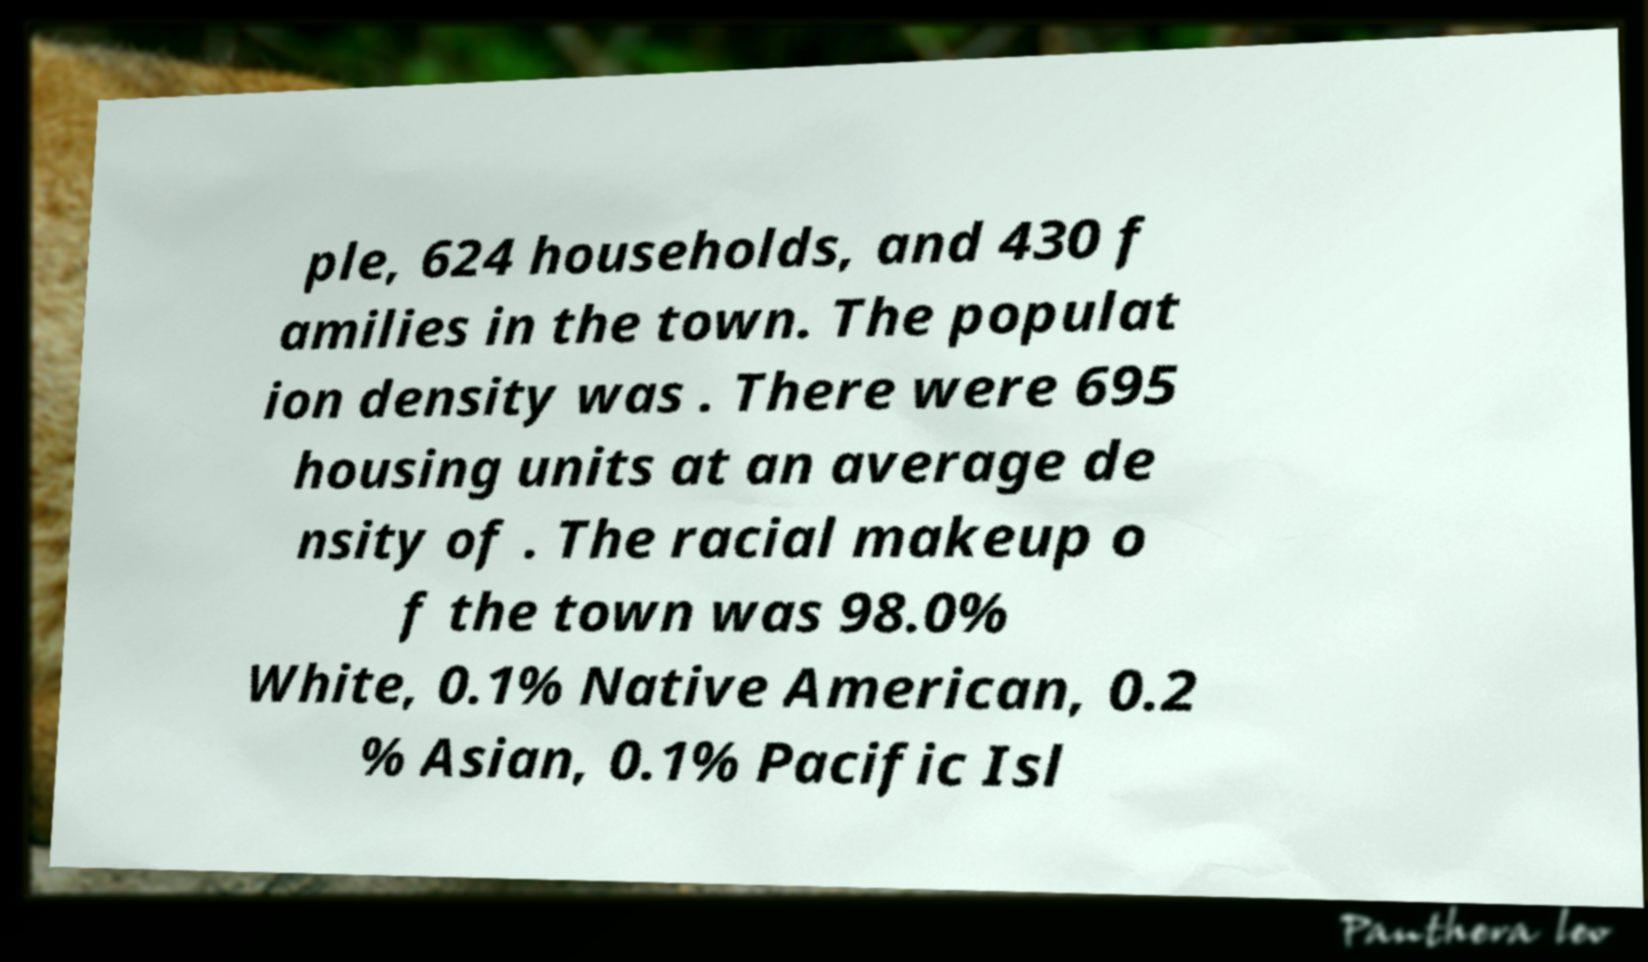Can you accurately transcribe the text from the provided image for me? ple, 624 households, and 430 f amilies in the town. The populat ion density was . There were 695 housing units at an average de nsity of . The racial makeup o f the town was 98.0% White, 0.1% Native American, 0.2 % Asian, 0.1% Pacific Isl 